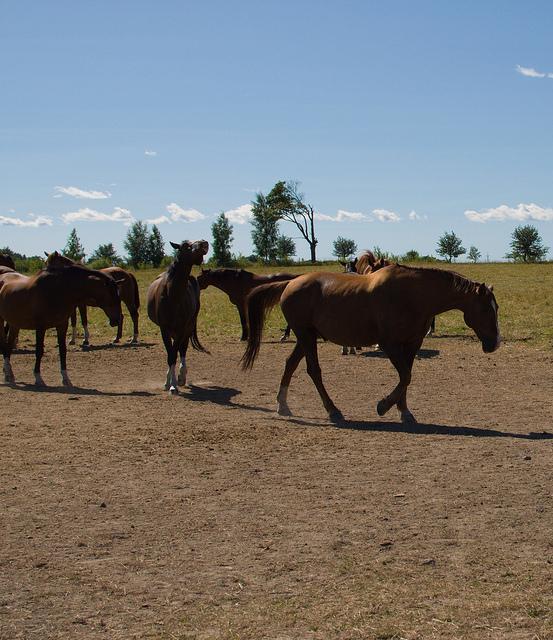How many riders are mounted on these horses?
Give a very brief answer. 0. How many horses can you see?
Give a very brief answer. 3. 